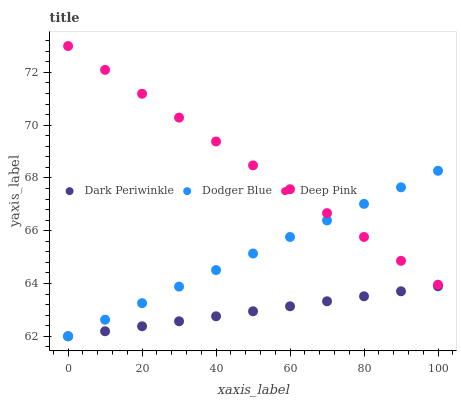Does Dark Periwinkle have the minimum area under the curve?
Answer yes or no. Yes. Does Deep Pink have the maximum area under the curve?
Answer yes or no. Yes. Does Dodger Blue have the minimum area under the curve?
Answer yes or no. No. Does Dodger Blue have the maximum area under the curve?
Answer yes or no. No. Is Dark Periwinkle the smoothest?
Answer yes or no. Yes. Is Dodger Blue the roughest?
Answer yes or no. Yes. Is Dodger Blue the smoothest?
Answer yes or no. No. Is Dark Periwinkle the roughest?
Answer yes or no. No. Does Dodger Blue have the lowest value?
Answer yes or no. Yes. Does Deep Pink have the highest value?
Answer yes or no. Yes. Does Dodger Blue have the highest value?
Answer yes or no. No. Is Dark Periwinkle less than Deep Pink?
Answer yes or no. Yes. Is Deep Pink greater than Dark Periwinkle?
Answer yes or no. Yes. Does Dodger Blue intersect Deep Pink?
Answer yes or no. Yes. Is Dodger Blue less than Deep Pink?
Answer yes or no. No. Is Dodger Blue greater than Deep Pink?
Answer yes or no. No. Does Dark Periwinkle intersect Deep Pink?
Answer yes or no. No. 